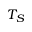Convert formula to latex. <formula><loc_0><loc_0><loc_500><loc_500>T _ { S }</formula> 